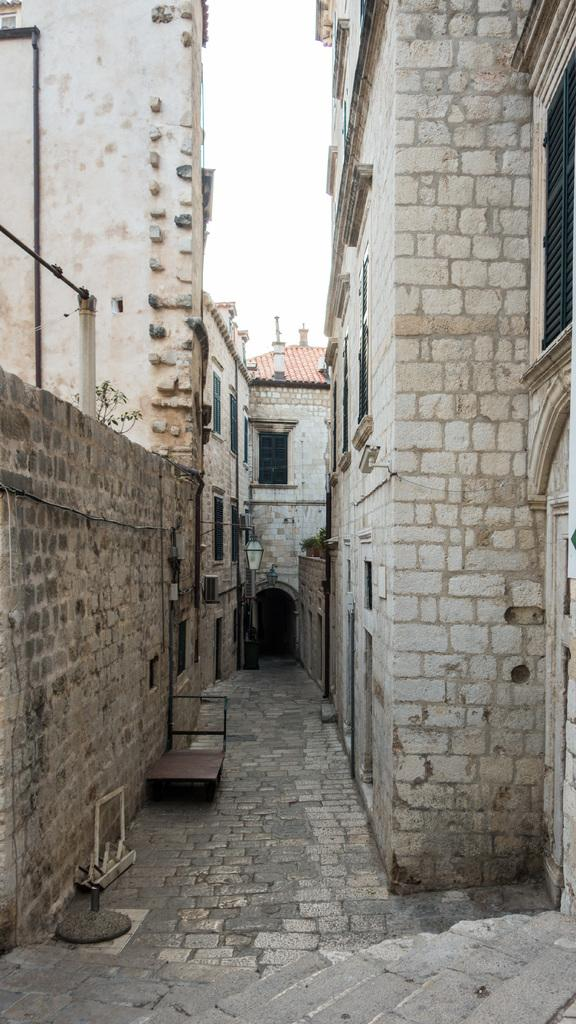What type of structures can be seen in the image? There are buildings in the image. What feature is visible on the buildings? There are windows visible in the image. What mode of transportation is present in the image? There is a trolley in the image. What is the color of the sky in the background? The sky in the background appears to be white. Can you tell me how many brothers are standing next to the trolley in the image? There is no mention of a brother or any people in the image; it only features buildings, windows, a trolley, and a white sky. 